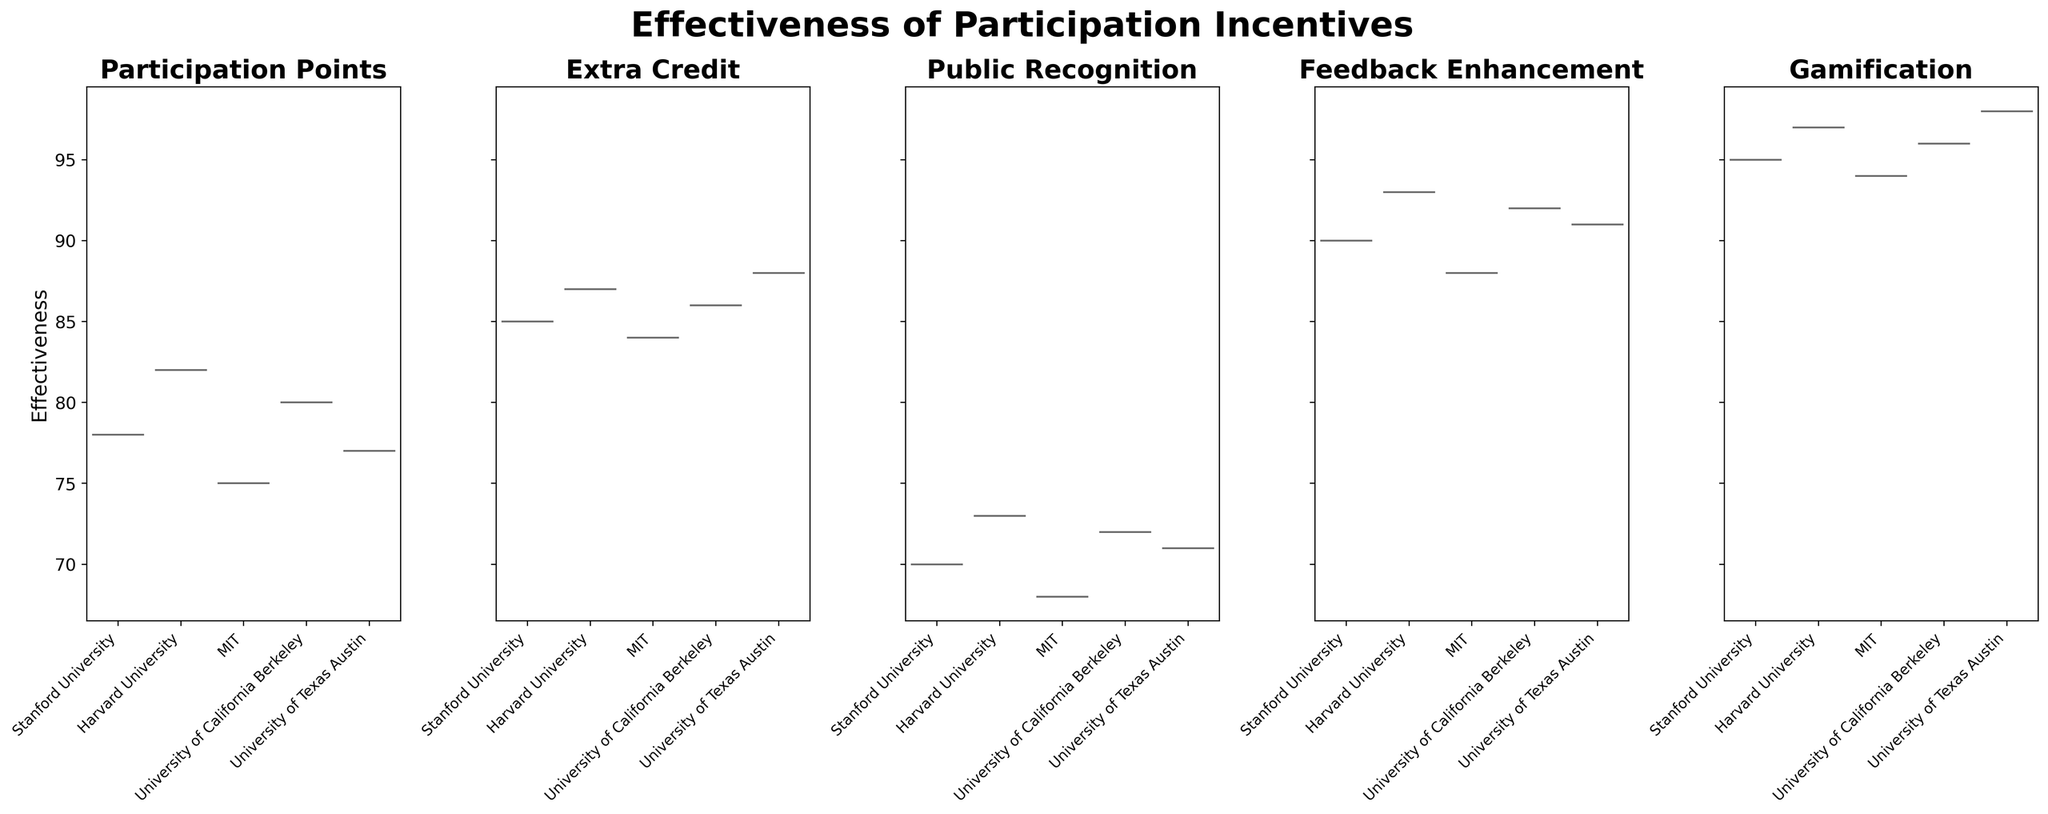Which method shows the highest overall effectiveness across institutions? By looking at the plot, we can see that Gamification has the highest effectiveness values across all institutions.
Answer: Gamification Which institutions have similar median effectiveness for Feedback Enhancement? From the violin plot, we can observe the median indicators (white dots). Stanford University and University of Texas Austin have closely aligned medians for Feedback Enhancement.
Answer: Stanford University and University of Texas Austin What's the difference in median effectiveness between Public Recognition and Extra Credit at MIT? Locate the median values for both methods at MIT by observing the respective violin plots. The median for Public Recognition is 68, and for Extra Credit, it is 84. The difference is 84 - 68.
Answer: 16 Which method has the widest distribution of effectiveness scores? By observing the width of the violin plots, Public Recognition shows the widest spread compared to the other methods.
Answer: Public Recognition Do any methods show a perfectly symmetric distribution across all institutions? All methods in the violin plots have some degree of asymmetry, but Participation Points comes closest to a symmetric distribution.
Answer: No Which institution shows the highest average effectiveness across all methods? Observing the centers and spreads of the violins for each institution, Harvard University consistently has high median values across most methods, suggesting a high average effectiveness.
Answer: Harvard University How does the median effectiveness of Gamification compare between Stanford University and Harvard University? Refer to the white dots for Gamification in both subplots. The median effectiveness for Stanford University is 95, and for Harvard University, it is 97.
Answer: Harvard University is higher Which institutions have overlapping distributions in the Extra Credit method? The violin plot for Extra Credit shows considerable overlap among all five institutions. However, Stanford University, University of California Berkeley, and University of Texas Austin exhibit the most significant overlap.
Answer: Stanford University, University of California Berkeley, University of Texas Austin Are there any institutions where the effectiveness of Gamification is not the highest compared to the other methods? By examining Gamification across institutions, we can see that in all cases, Gamification has the highest values, meaning it is the highest for every institution.
Answer: No 